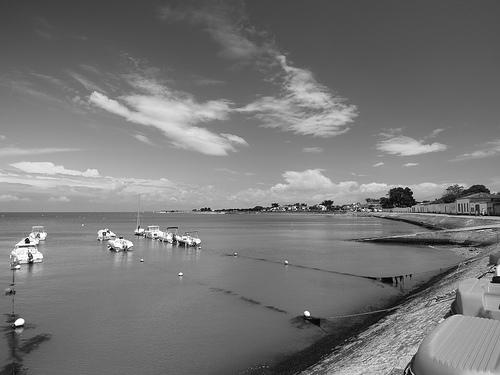Mention the main subject and style of the image. The main subject is the shore and ocean with boats, and the image is in monochromatic style. Give an overall depiction of the atmosphere and scenery in the image. The image features a beautiful, calm beach with clear skies, white clouds, transparent water, and boats gathered around the shore. Explain the scene involving boats and what stands out about them. White boats are sitting in the bay on calm, transparent sea water, with some boats appearing as dark spots in the water. Mention the most prominent feature of the weather in the image. Partly cloudy weather with white clouds scattered in a blue sky. Provide a brief description of the main elements seen in the image. A beach with transparent water, boats in the bay, high cloud formations, white clouds in blue sky, and a tree in the background. Point out the main characteristics of the sky and clouds in the image. The sky is clear and bright with a mix of high clouds and white clouds scattered across the blue sky. Identify the type of location and nature of the scene in the image. The image depicts a peaceful seaside scene, featuring a beach with clear skies, calm waters, and boats anchored nearby. Comment on the overall colors used in the image. The image is mostly black and white with some regions in monochromatic style, featuring deep shades of black, white, and gray. Describe any structures or objects near the water in the image. There is a white house near the sea, a ramp near the sea, a rope hanging near the sea, and a white speed boat on the water. Describe the appearance and location of the water in the image. The ocean water is very transparent and calm with dark spots present, stretching from the shore to the boats in the bay. 